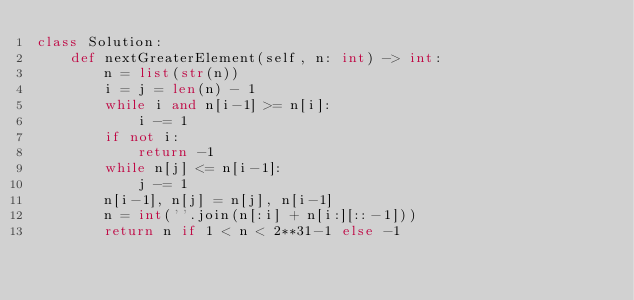<code> <loc_0><loc_0><loc_500><loc_500><_Python_>class Solution:
    def nextGreaterElement(self, n: int) -> int:
        n = list(str(n))
        i = j = len(n) - 1
        while i and n[i-1] >= n[i]:
            i -= 1
        if not i:
            return -1
        while n[j] <= n[i-1]:
            j -= 1
        n[i-1], n[j] = n[j], n[i-1]
        n = int(''.join(n[:i] + n[i:][::-1]))
        return n if 1 < n < 2**31-1 else -1
        </code> 